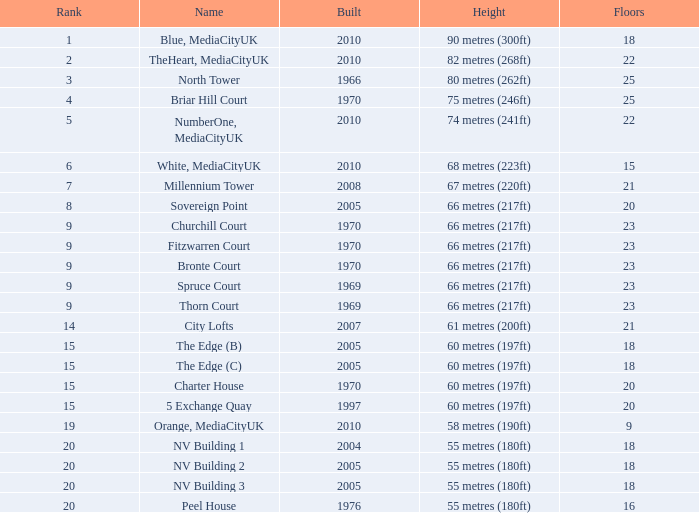Parse the table in full. {'header': ['Rank', 'Name', 'Built', 'Height', 'Floors'], 'rows': [['1', 'Blue, MediaCityUK', '2010', '90 metres (300ft)', '18'], ['2', 'TheHeart, MediaCityUK', '2010', '82 metres (268ft)', '22'], ['3', 'North Tower', '1966', '80 metres (262ft)', '25'], ['4', 'Briar Hill Court', '1970', '75 metres (246ft)', '25'], ['5', 'NumberOne, MediaCityUK', '2010', '74 metres (241ft)', '22'], ['6', 'White, MediaCityUK', '2010', '68 metres (223ft)', '15'], ['7', 'Millennium Tower', '2008', '67 metres (220ft)', '21'], ['8', 'Sovereign Point', '2005', '66 metres (217ft)', '20'], ['9', 'Churchill Court', '1970', '66 metres (217ft)', '23'], ['9', 'Fitzwarren Court', '1970', '66 metres (217ft)', '23'], ['9', 'Bronte Court', '1970', '66 metres (217ft)', '23'], ['9', 'Spruce Court', '1969', '66 metres (217ft)', '23'], ['9', 'Thorn Court', '1969', '66 metres (217ft)', '23'], ['14', 'City Lofts', '2007', '61 metres (200ft)', '21'], ['15', 'The Edge (B)', '2005', '60 metres (197ft)', '18'], ['15', 'The Edge (C)', '2005', '60 metres (197ft)', '18'], ['15', 'Charter House', '1970', '60 metres (197ft)', '20'], ['15', '5 Exchange Quay', '1997', '60 metres (197ft)', '20'], ['19', 'Orange, MediaCityUK', '2010', '58 metres (190ft)', '9'], ['20', 'NV Building 1', '2004', '55 metres (180ft)', '18'], ['20', 'NV Building 2', '2005', '55 metres (180ft)', '18'], ['20', 'NV Building 3', '2005', '55 metres (180ft)', '18'], ['20', 'Peel House', '1976', '55 metres (180ft)', '16']]} What is the verticality, when standing is lesser than 20, when layers is in excess of 9, when creation is 2005, and when appellation is the edge (c)? 60 metres (197ft). 